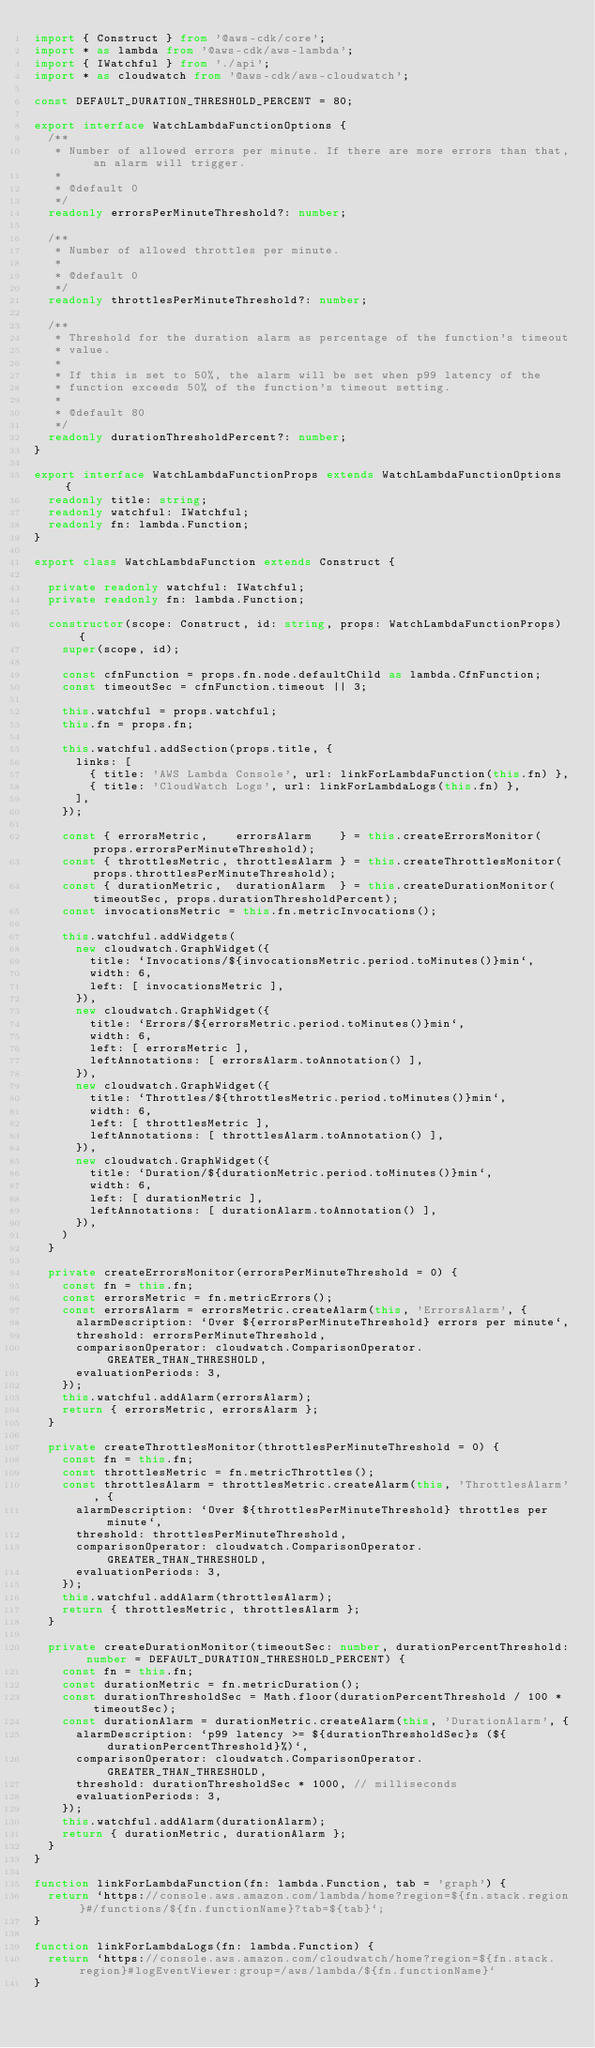Convert code to text. <code><loc_0><loc_0><loc_500><loc_500><_TypeScript_>import { Construct } from '@aws-cdk/core';
import * as lambda from '@aws-cdk/aws-lambda';
import { IWatchful } from './api';
import * as cloudwatch from '@aws-cdk/aws-cloudwatch';

const DEFAULT_DURATION_THRESHOLD_PERCENT = 80;

export interface WatchLambdaFunctionOptions {
  /**
   * Number of allowed errors per minute. If there are more errors than that, an alarm will trigger.
   *
   * @default 0
   */
  readonly errorsPerMinuteThreshold?: number;

  /**
   * Number of allowed throttles per minute.
   *
   * @default 0
   */
  readonly throttlesPerMinuteThreshold?: number;

  /**
   * Threshold for the duration alarm as percentage of the function's timeout
   * value.
   *
   * If this is set to 50%, the alarm will be set when p99 latency of the
   * function exceeds 50% of the function's timeout setting.
   *
   * @default 80
   */
  readonly durationThresholdPercent?: number;
}

export interface WatchLambdaFunctionProps extends WatchLambdaFunctionOptions {
  readonly title: string;
  readonly watchful: IWatchful;
  readonly fn: lambda.Function;
}

export class WatchLambdaFunction extends Construct {

  private readonly watchful: IWatchful;
  private readonly fn: lambda.Function;

  constructor(scope: Construct, id: string, props: WatchLambdaFunctionProps) {
    super(scope, id);

    const cfnFunction = props.fn.node.defaultChild as lambda.CfnFunction;
    const timeoutSec = cfnFunction.timeout || 3;

    this.watchful = props.watchful;
    this.fn = props.fn;

    this.watchful.addSection(props.title, {
      links: [
        { title: 'AWS Lambda Console', url: linkForLambdaFunction(this.fn) },
        { title: 'CloudWatch Logs', url: linkForLambdaLogs(this.fn) },
      ],
    });

    const { errorsMetric,    errorsAlarm    } = this.createErrorsMonitor(props.errorsPerMinuteThreshold);
    const { throttlesMetric, throttlesAlarm } = this.createThrottlesMonitor(props.throttlesPerMinuteThreshold);
    const { durationMetric,  durationAlarm  } = this.createDurationMonitor(timeoutSec, props.durationThresholdPercent);
    const invocationsMetric = this.fn.metricInvocations();

    this.watchful.addWidgets(
      new cloudwatch.GraphWidget({
        title: `Invocations/${invocationsMetric.period.toMinutes()}min`,
        width: 6,
        left: [ invocationsMetric ],
      }),
      new cloudwatch.GraphWidget({
        title: `Errors/${errorsMetric.period.toMinutes()}min`,
        width: 6,
        left: [ errorsMetric ],
        leftAnnotations: [ errorsAlarm.toAnnotation() ],
      }),
      new cloudwatch.GraphWidget({
        title: `Throttles/${throttlesMetric.period.toMinutes()}min`,
        width: 6,
        left: [ throttlesMetric ],
        leftAnnotations: [ throttlesAlarm.toAnnotation() ],
      }),
      new cloudwatch.GraphWidget({
        title: `Duration/${durationMetric.period.toMinutes()}min`,
        width: 6,
        left: [ durationMetric ],
        leftAnnotations: [ durationAlarm.toAnnotation() ],
      }),
    )
  }

  private createErrorsMonitor(errorsPerMinuteThreshold = 0) {
    const fn = this.fn;
    const errorsMetric = fn.metricErrors();
    const errorsAlarm = errorsMetric.createAlarm(this, 'ErrorsAlarm', {
      alarmDescription: `Over ${errorsPerMinuteThreshold} errors per minute`,
      threshold: errorsPerMinuteThreshold,
      comparisonOperator: cloudwatch.ComparisonOperator.GREATER_THAN_THRESHOLD,
      evaluationPeriods: 3,
    });
    this.watchful.addAlarm(errorsAlarm);
    return { errorsMetric, errorsAlarm };
  }

  private createThrottlesMonitor(throttlesPerMinuteThreshold = 0) {
    const fn = this.fn;
    const throttlesMetric = fn.metricThrottles();
    const throttlesAlarm = throttlesMetric.createAlarm(this, 'ThrottlesAlarm', {
      alarmDescription: `Over ${throttlesPerMinuteThreshold} throttles per minute`,
      threshold: throttlesPerMinuteThreshold,
      comparisonOperator: cloudwatch.ComparisonOperator.GREATER_THAN_THRESHOLD,
      evaluationPeriods: 3,
    });
    this.watchful.addAlarm(throttlesAlarm);
    return { throttlesMetric, throttlesAlarm };
  }

  private createDurationMonitor(timeoutSec: number, durationPercentThreshold: number = DEFAULT_DURATION_THRESHOLD_PERCENT) {
    const fn = this.fn;
    const durationMetric = fn.metricDuration();
    const durationThresholdSec = Math.floor(durationPercentThreshold / 100 * timeoutSec);
    const durationAlarm = durationMetric.createAlarm(this, 'DurationAlarm', {
      alarmDescription: `p99 latency >= ${durationThresholdSec}s (${durationPercentThreshold}%)`,
      comparisonOperator: cloudwatch.ComparisonOperator.GREATER_THAN_THRESHOLD,
      threshold: durationThresholdSec * 1000, // milliseconds
      evaluationPeriods: 3,
    });
    this.watchful.addAlarm(durationAlarm);
    return { durationMetric, durationAlarm };
  }
}

function linkForLambdaFunction(fn: lambda.Function, tab = 'graph') {
  return `https://console.aws.amazon.com/lambda/home?region=${fn.stack.region}#/functions/${fn.functionName}?tab=${tab}`;
}

function linkForLambdaLogs(fn: lambda.Function) {
  return `https://console.aws.amazon.com/cloudwatch/home?region=${fn.stack.region}#logEventViewer:group=/aws/lambda/${fn.functionName}`
}</code> 